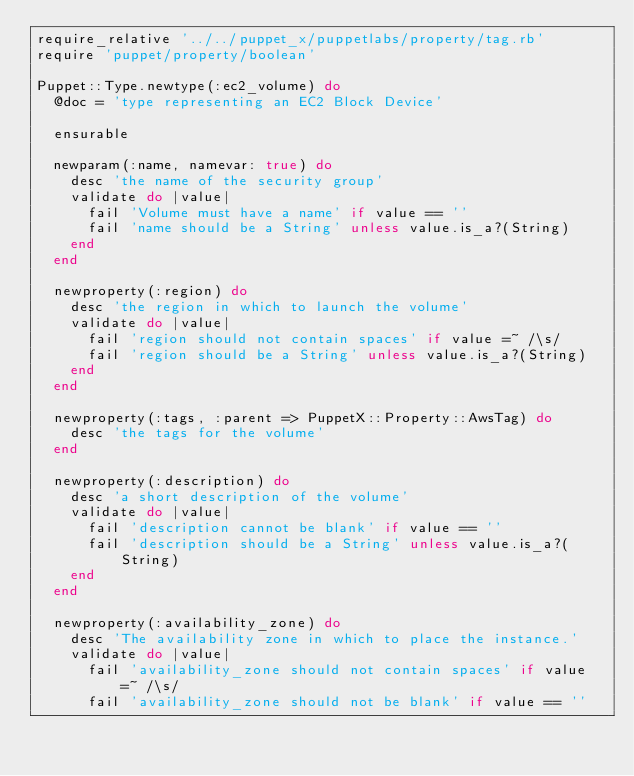<code> <loc_0><loc_0><loc_500><loc_500><_Ruby_>require_relative '../../puppet_x/puppetlabs/property/tag.rb'
require 'puppet/property/boolean'

Puppet::Type.newtype(:ec2_volume) do
  @doc = 'type representing an EC2 Block Device'

  ensurable

  newparam(:name, namevar: true) do
    desc 'the name of the security group'
    validate do |value|
      fail 'Volume must have a name' if value == ''
      fail 'name should be a String' unless value.is_a?(String)
    end
  end

  newproperty(:region) do
    desc 'the region in which to launch the volume'
    validate do |value|
      fail 'region should not contain spaces' if value =~ /\s/
      fail 'region should be a String' unless value.is_a?(String)
    end
  end

  newproperty(:tags, :parent => PuppetX::Property::AwsTag) do
    desc 'the tags for the volume'
  end

  newproperty(:description) do
    desc 'a short description of the volume'
    validate do |value|
      fail 'description cannot be blank' if value == ''
      fail 'description should be a String' unless value.is_a?(String)
    end
  end

  newproperty(:availability_zone) do
    desc 'The availability zone in which to place the instance.'
    validate do |value|
      fail 'availability_zone should not contain spaces' if value =~ /\s/
      fail 'availability_zone should not be blank' if value == ''</code> 